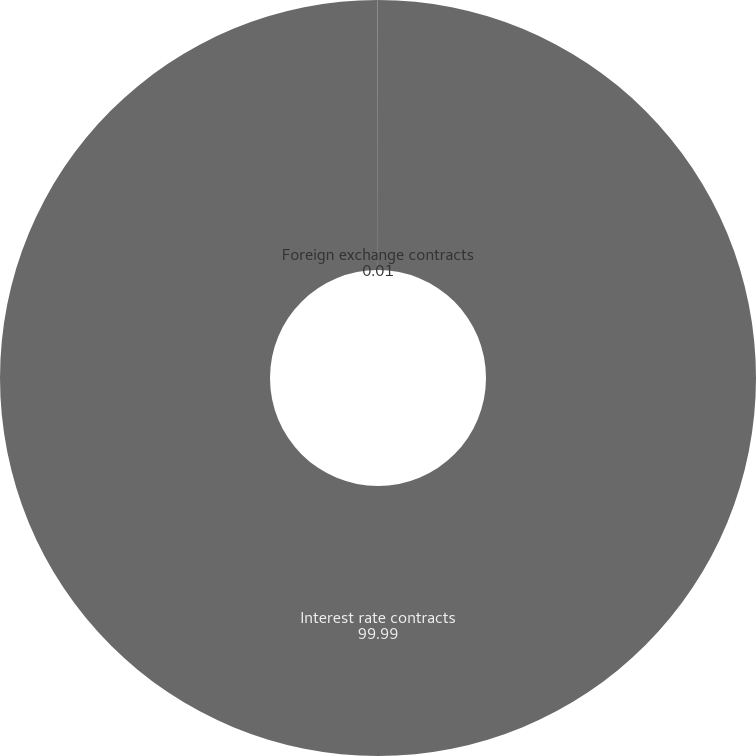Convert chart. <chart><loc_0><loc_0><loc_500><loc_500><pie_chart><fcel>Interest rate contracts<fcel>Foreign exchange contracts<nl><fcel>99.99%<fcel>0.01%<nl></chart> 